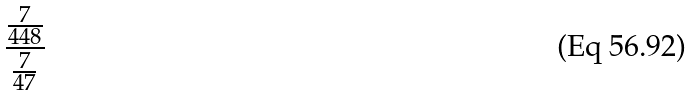Convert formula to latex. <formula><loc_0><loc_0><loc_500><loc_500>\frac { \frac { 7 } { 4 4 8 } } { \frac { 7 } { 4 7 } }</formula> 